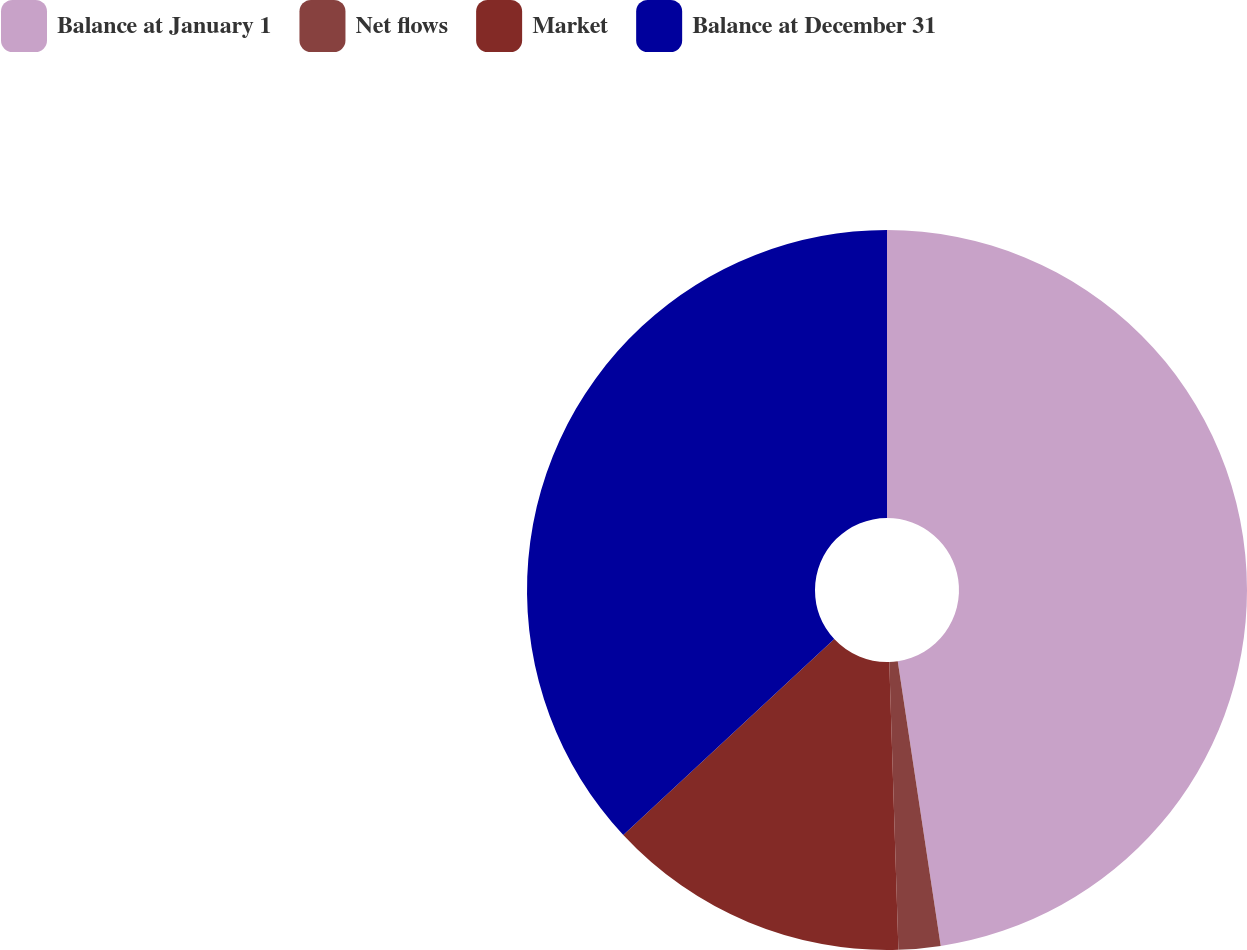Convert chart to OTSL. <chart><loc_0><loc_0><loc_500><loc_500><pie_chart><fcel>Balance at January 1<fcel>Net flows<fcel>Market<fcel>Balance at December 31<nl><fcel>47.62%<fcel>1.88%<fcel>13.59%<fcel>36.92%<nl></chart> 